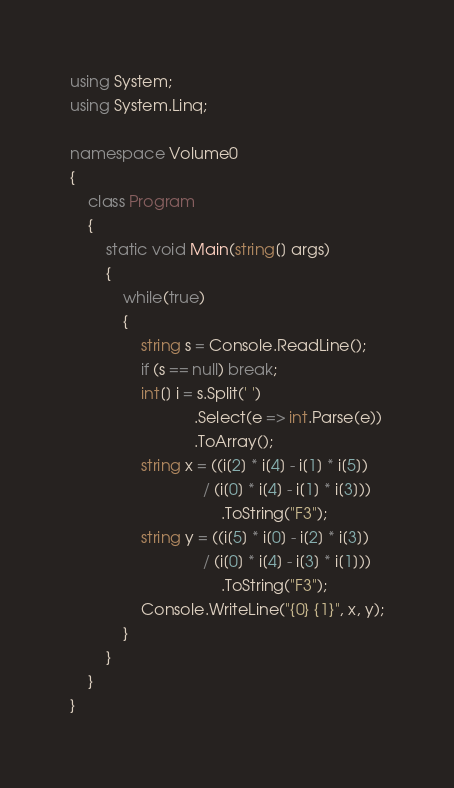Convert code to text. <code><loc_0><loc_0><loc_500><loc_500><_C#_>using System;
using System.Linq;

namespace Volume0
{
    class Program
    {
        static void Main(string[] args)
        {
            while(true)
            {
                string s = Console.ReadLine();
                if (s == null) break;
                int[] i = s.Split(' ')
                            .Select(e => int.Parse(e))
                            .ToArray();
                string x = ((i[2] * i[4] - i[1] * i[5]) 
                              / (i[0] * i[4] - i[1] * i[3]))
                                  .ToString("F3");
                string y = ((i[5] * i[0] - i[2] * i[3])
                              / (i[0] * i[4] - i[3] * i[1]))
                                  .ToString("F3");
                Console.WriteLine("{0} {1}", x, y);
            }
        }
    }
}</code> 